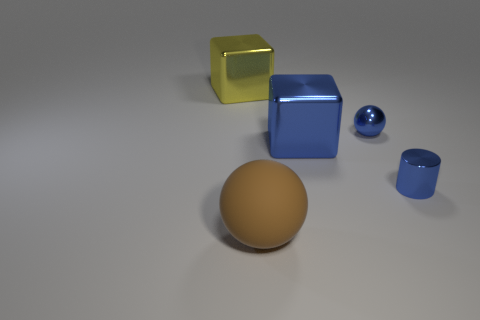Subtract all blue spheres. How many spheres are left? 1 Subtract all cyan balls. How many yellow blocks are left? 1 Add 2 gray rubber things. How many objects exist? 7 Subtract 1 balls. How many balls are left? 1 Subtract all cylinders. How many objects are left? 4 Subtract all cyan balls. Subtract all purple cylinders. How many balls are left? 2 Subtract all brown things. Subtract all large yellow blocks. How many objects are left? 3 Add 4 brown balls. How many brown balls are left? 5 Add 2 tiny blue objects. How many tiny blue objects exist? 4 Subtract 1 brown balls. How many objects are left? 4 